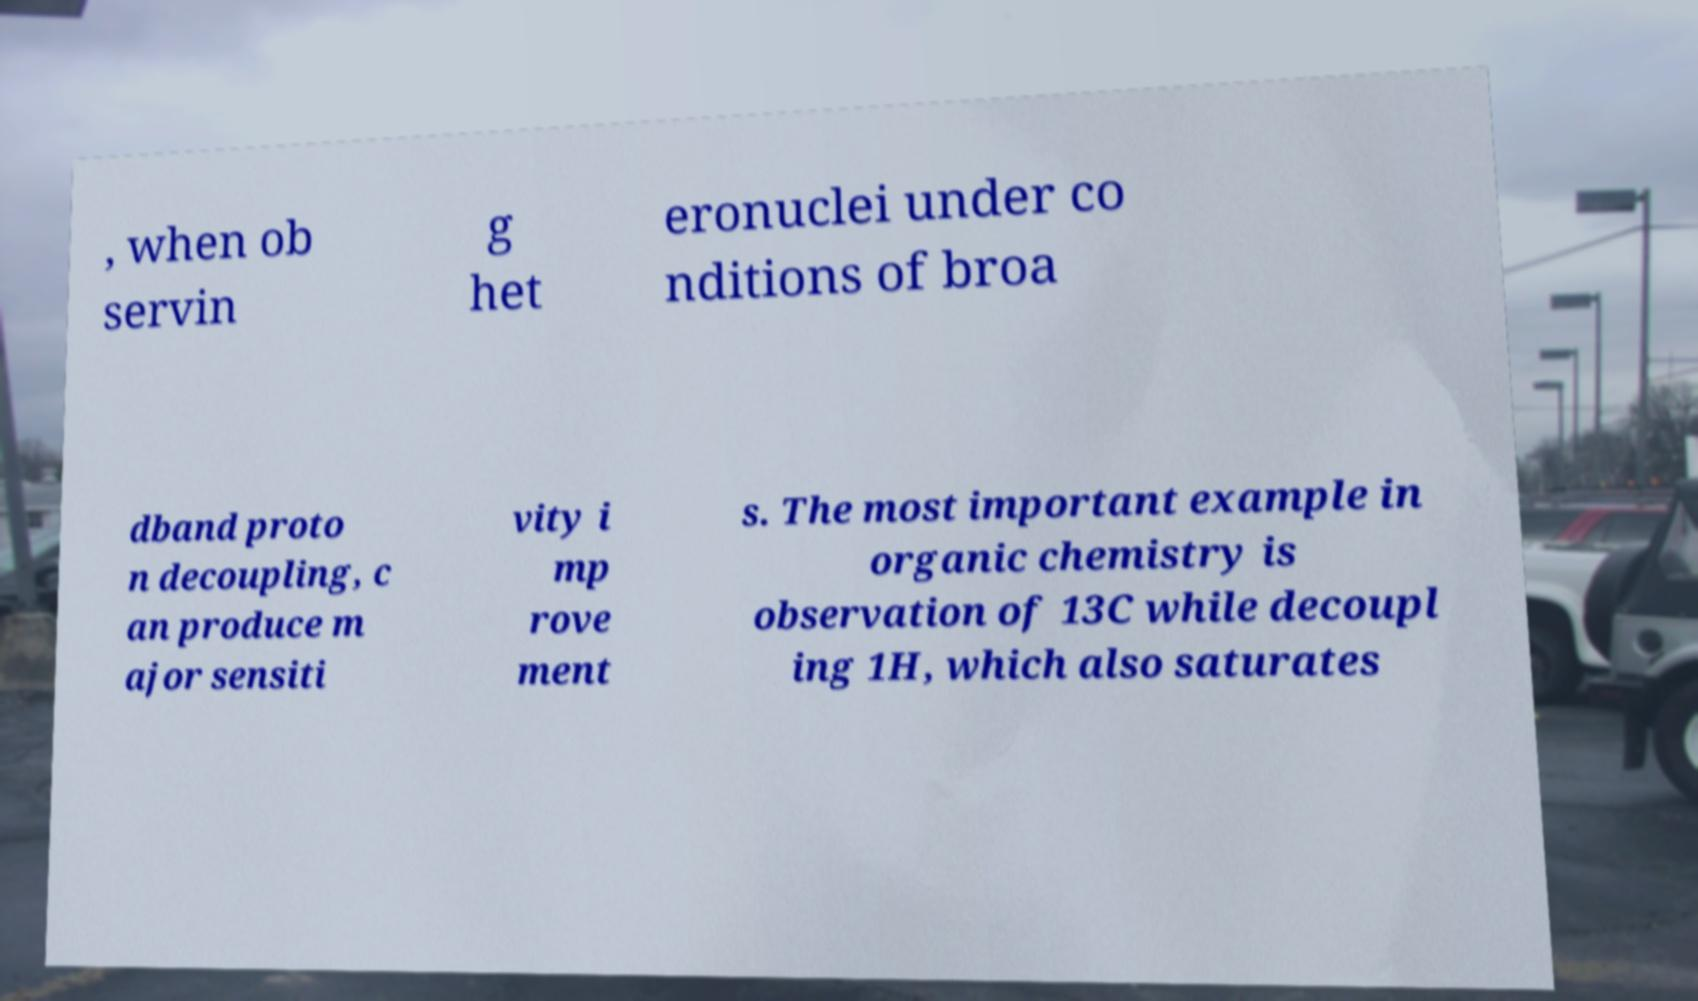Please read and relay the text visible in this image. What does it say? , when ob servin g het eronuclei under co nditions of broa dband proto n decoupling, c an produce m ajor sensiti vity i mp rove ment s. The most important example in organic chemistry is observation of 13C while decoupl ing 1H, which also saturates 